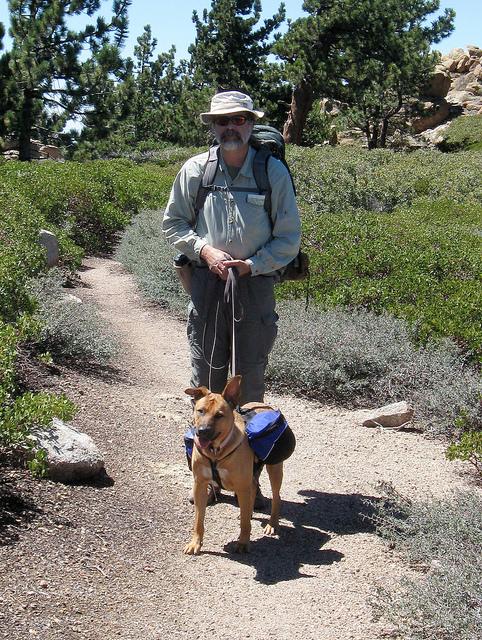What kind of hat is the man wearing?
Short answer required. Sun hat. Is someone wearing a knit hat?
Answer briefly. No. Is the man the owner of the dog?
Give a very brief answer. Yes. What activity are they doing?
Give a very brief answer. Hiking. 